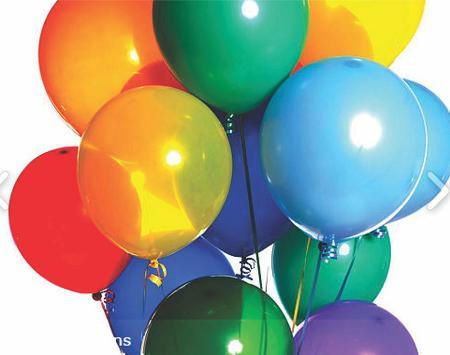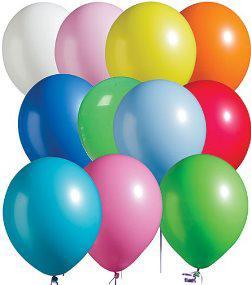The first image is the image on the left, the second image is the image on the right. For the images shown, is this caption "The left and right image contains a bushel of balloons with strings and at least two balloons are green," true? Answer yes or no. Yes. 